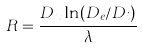<formula> <loc_0><loc_0><loc_500><loc_500>R = \frac { D _ { x } \ln ( D _ { e } / D _ { i } ) } { \lambda }</formula> 